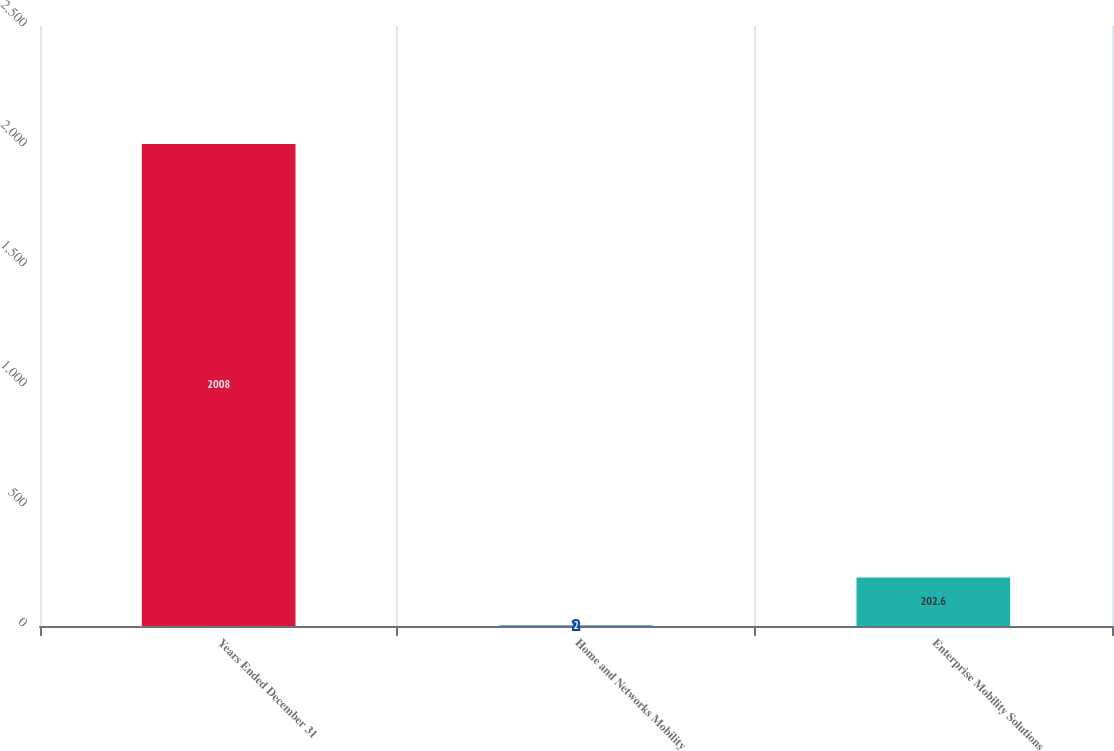Convert chart. <chart><loc_0><loc_0><loc_500><loc_500><bar_chart><fcel>Years Ended December 31<fcel>Home and Networks Mobility<fcel>Enterprise Mobility Solutions<nl><fcel>2008<fcel>2<fcel>202.6<nl></chart> 